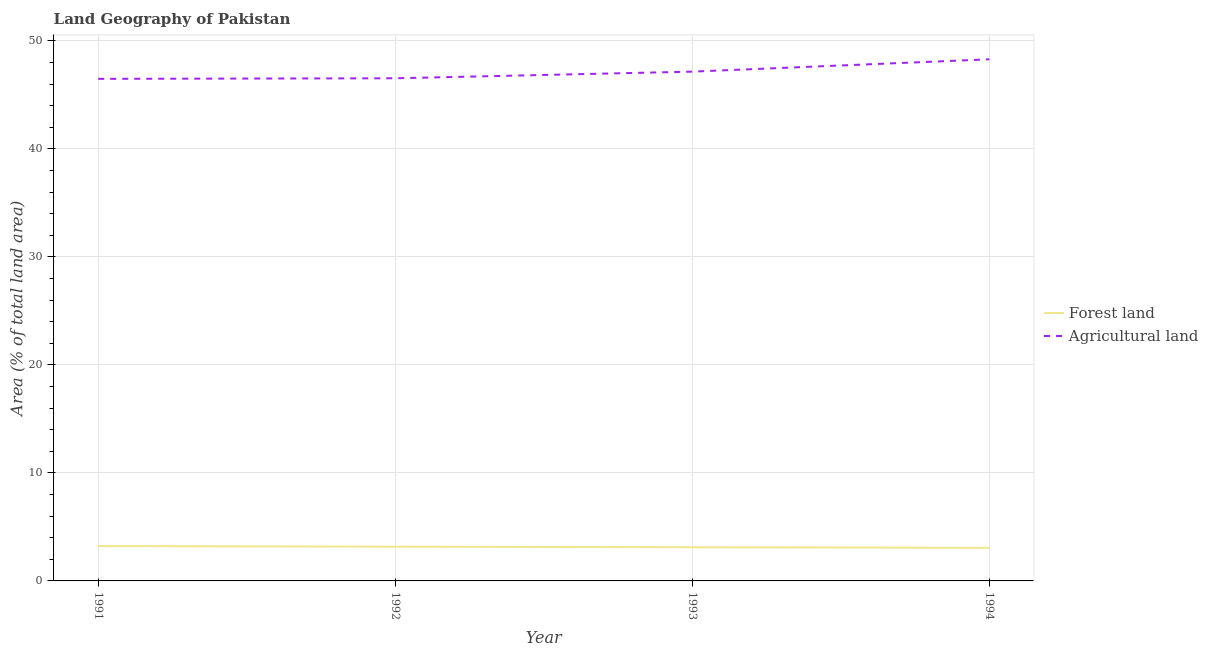How many different coloured lines are there?
Provide a short and direct response. 2. Does the line corresponding to percentage of land area under forests intersect with the line corresponding to percentage of land area under agriculture?
Give a very brief answer. No. Is the number of lines equal to the number of legend labels?
Provide a succinct answer. Yes. What is the percentage of land area under agriculture in 1991?
Offer a terse response. 46.49. Across all years, what is the maximum percentage of land area under agriculture?
Provide a succinct answer. 48.3. Across all years, what is the minimum percentage of land area under forests?
Your response must be concise. 3.06. In which year was the percentage of land area under agriculture maximum?
Your answer should be compact. 1994. In which year was the percentage of land area under agriculture minimum?
Your answer should be very brief. 1991. What is the total percentage of land area under agriculture in the graph?
Your response must be concise. 188.5. What is the difference between the percentage of land area under forests in 1992 and that in 1993?
Ensure brevity in your answer.  0.05. What is the difference between the percentage of land area under agriculture in 1994 and the percentage of land area under forests in 1993?
Make the answer very short. 45.18. What is the average percentage of land area under agriculture per year?
Offer a very short reply. 47.12. In the year 1991, what is the difference between the percentage of land area under agriculture and percentage of land area under forests?
Keep it short and to the point. 43.27. In how many years, is the percentage of land area under forests greater than 6 %?
Give a very brief answer. 0. What is the ratio of the percentage of land area under agriculture in 1992 to that in 1993?
Make the answer very short. 0.99. Is the difference between the percentage of land area under agriculture in 1992 and 1993 greater than the difference between the percentage of land area under forests in 1992 and 1993?
Provide a short and direct response. No. What is the difference between the highest and the second highest percentage of land area under forests?
Your answer should be compact. 0.05. What is the difference between the highest and the lowest percentage of land area under forests?
Your answer should be compact. 0.16. In how many years, is the percentage of land area under agriculture greater than the average percentage of land area under agriculture taken over all years?
Ensure brevity in your answer.  2. How many lines are there?
Your response must be concise. 2. Are the values on the major ticks of Y-axis written in scientific E-notation?
Give a very brief answer. No. Does the graph contain any zero values?
Ensure brevity in your answer.  No. How are the legend labels stacked?
Provide a succinct answer. Vertical. What is the title of the graph?
Give a very brief answer. Land Geography of Pakistan. What is the label or title of the X-axis?
Keep it short and to the point. Year. What is the label or title of the Y-axis?
Provide a short and direct response. Area (% of total land area). What is the Area (% of total land area) of Forest land in 1991?
Offer a very short reply. 3.22. What is the Area (% of total land area) in Agricultural land in 1991?
Ensure brevity in your answer.  46.49. What is the Area (% of total land area) of Forest land in 1992?
Your answer should be very brief. 3.17. What is the Area (% of total land area) of Agricultural land in 1992?
Provide a succinct answer. 46.54. What is the Area (% of total land area) of Forest land in 1993?
Your answer should be very brief. 3.12. What is the Area (% of total land area) in Agricultural land in 1993?
Give a very brief answer. 47.16. What is the Area (% of total land area) of Forest land in 1994?
Provide a short and direct response. 3.06. What is the Area (% of total land area) of Agricultural land in 1994?
Offer a very short reply. 48.3. Across all years, what is the maximum Area (% of total land area) of Forest land?
Your answer should be very brief. 3.22. Across all years, what is the maximum Area (% of total land area) of Agricultural land?
Your response must be concise. 48.3. Across all years, what is the minimum Area (% of total land area) of Forest land?
Ensure brevity in your answer.  3.06. Across all years, what is the minimum Area (% of total land area) in Agricultural land?
Make the answer very short. 46.49. What is the total Area (% of total land area) in Forest land in the graph?
Your response must be concise. 12.58. What is the total Area (% of total land area) in Agricultural land in the graph?
Offer a terse response. 188.5. What is the difference between the Area (% of total land area) of Forest land in 1991 and that in 1992?
Your response must be concise. 0.05. What is the difference between the Area (% of total land area) in Agricultural land in 1991 and that in 1992?
Provide a succinct answer. -0.05. What is the difference between the Area (% of total land area) in Forest land in 1991 and that in 1993?
Offer a terse response. 0.11. What is the difference between the Area (% of total land area) in Agricultural land in 1991 and that in 1993?
Give a very brief answer. -0.67. What is the difference between the Area (% of total land area) in Forest land in 1991 and that in 1994?
Make the answer very short. 0.16. What is the difference between the Area (% of total land area) of Agricultural land in 1991 and that in 1994?
Make the answer very short. -1.81. What is the difference between the Area (% of total land area) of Forest land in 1992 and that in 1993?
Offer a terse response. 0.05. What is the difference between the Area (% of total land area) in Agricultural land in 1992 and that in 1993?
Provide a short and direct response. -0.62. What is the difference between the Area (% of total land area) in Forest land in 1992 and that in 1994?
Your response must be concise. 0.11. What is the difference between the Area (% of total land area) in Agricultural land in 1992 and that in 1994?
Offer a very short reply. -1.76. What is the difference between the Area (% of total land area) of Forest land in 1993 and that in 1994?
Give a very brief answer. 0.05. What is the difference between the Area (% of total land area) of Agricultural land in 1993 and that in 1994?
Your answer should be compact. -1.14. What is the difference between the Area (% of total land area) in Forest land in 1991 and the Area (% of total land area) in Agricultural land in 1992?
Provide a succinct answer. -43.32. What is the difference between the Area (% of total land area) of Forest land in 1991 and the Area (% of total land area) of Agricultural land in 1993?
Provide a succinct answer. -43.94. What is the difference between the Area (% of total land area) of Forest land in 1991 and the Area (% of total land area) of Agricultural land in 1994?
Give a very brief answer. -45.08. What is the difference between the Area (% of total land area) in Forest land in 1992 and the Area (% of total land area) in Agricultural land in 1993?
Keep it short and to the point. -43.99. What is the difference between the Area (% of total land area) in Forest land in 1992 and the Area (% of total land area) in Agricultural land in 1994?
Your answer should be compact. -45.13. What is the difference between the Area (% of total land area) in Forest land in 1993 and the Area (% of total land area) in Agricultural land in 1994?
Keep it short and to the point. -45.18. What is the average Area (% of total land area) of Forest land per year?
Make the answer very short. 3.14. What is the average Area (% of total land area) in Agricultural land per year?
Your answer should be very brief. 47.12. In the year 1991, what is the difference between the Area (% of total land area) in Forest land and Area (% of total land area) in Agricultural land?
Give a very brief answer. -43.27. In the year 1992, what is the difference between the Area (% of total land area) in Forest land and Area (% of total land area) in Agricultural land?
Give a very brief answer. -43.37. In the year 1993, what is the difference between the Area (% of total land area) of Forest land and Area (% of total land area) of Agricultural land?
Make the answer very short. -44.04. In the year 1994, what is the difference between the Area (% of total land area) in Forest land and Area (% of total land area) in Agricultural land?
Offer a terse response. -45.24. What is the ratio of the Area (% of total land area) of Forest land in 1991 to that in 1992?
Offer a terse response. 1.02. What is the ratio of the Area (% of total land area) of Forest land in 1991 to that in 1993?
Your answer should be compact. 1.03. What is the ratio of the Area (% of total land area) in Agricultural land in 1991 to that in 1993?
Provide a short and direct response. 0.99. What is the ratio of the Area (% of total land area) of Forest land in 1991 to that in 1994?
Keep it short and to the point. 1.05. What is the ratio of the Area (% of total land area) of Agricultural land in 1991 to that in 1994?
Make the answer very short. 0.96. What is the ratio of the Area (% of total land area) in Forest land in 1992 to that in 1993?
Offer a very short reply. 1.02. What is the ratio of the Area (% of total land area) in Agricultural land in 1992 to that in 1993?
Provide a succinct answer. 0.99. What is the ratio of the Area (% of total land area) in Forest land in 1992 to that in 1994?
Provide a short and direct response. 1.03. What is the ratio of the Area (% of total land area) of Agricultural land in 1992 to that in 1994?
Make the answer very short. 0.96. What is the ratio of the Area (% of total land area) of Forest land in 1993 to that in 1994?
Offer a terse response. 1.02. What is the ratio of the Area (% of total land area) of Agricultural land in 1993 to that in 1994?
Provide a short and direct response. 0.98. What is the difference between the highest and the second highest Area (% of total land area) of Forest land?
Offer a terse response. 0.05. What is the difference between the highest and the second highest Area (% of total land area) in Agricultural land?
Offer a very short reply. 1.14. What is the difference between the highest and the lowest Area (% of total land area) of Forest land?
Offer a very short reply. 0.16. What is the difference between the highest and the lowest Area (% of total land area) of Agricultural land?
Make the answer very short. 1.81. 